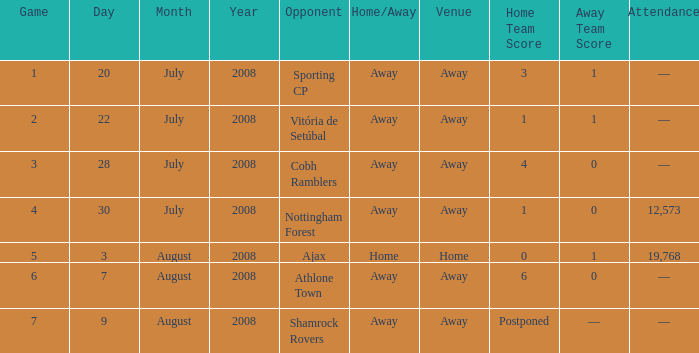What is the venue of game 3? Away. 